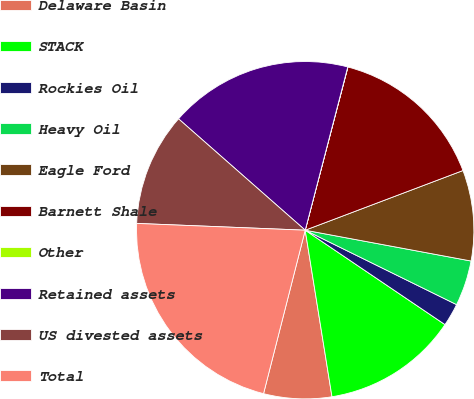Convert chart to OTSL. <chart><loc_0><loc_0><loc_500><loc_500><pie_chart><fcel>Delaware Basin<fcel>STACK<fcel>Rockies Oil<fcel>Heavy Oil<fcel>Eagle Ford<fcel>Barnett Shale<fcel>Other<fcel>Retained assets<fcel>US divested assets<fcel>Total<nl><fcel>6.51%<fcel>13.01%<fcel>2.18%<fcel>4.35%<fcel>8.68%<fcel>15.17%<fcel>0.02%<fcel>17.58%<fcel>10.84%<fcel>21.67%<nl></chart> 